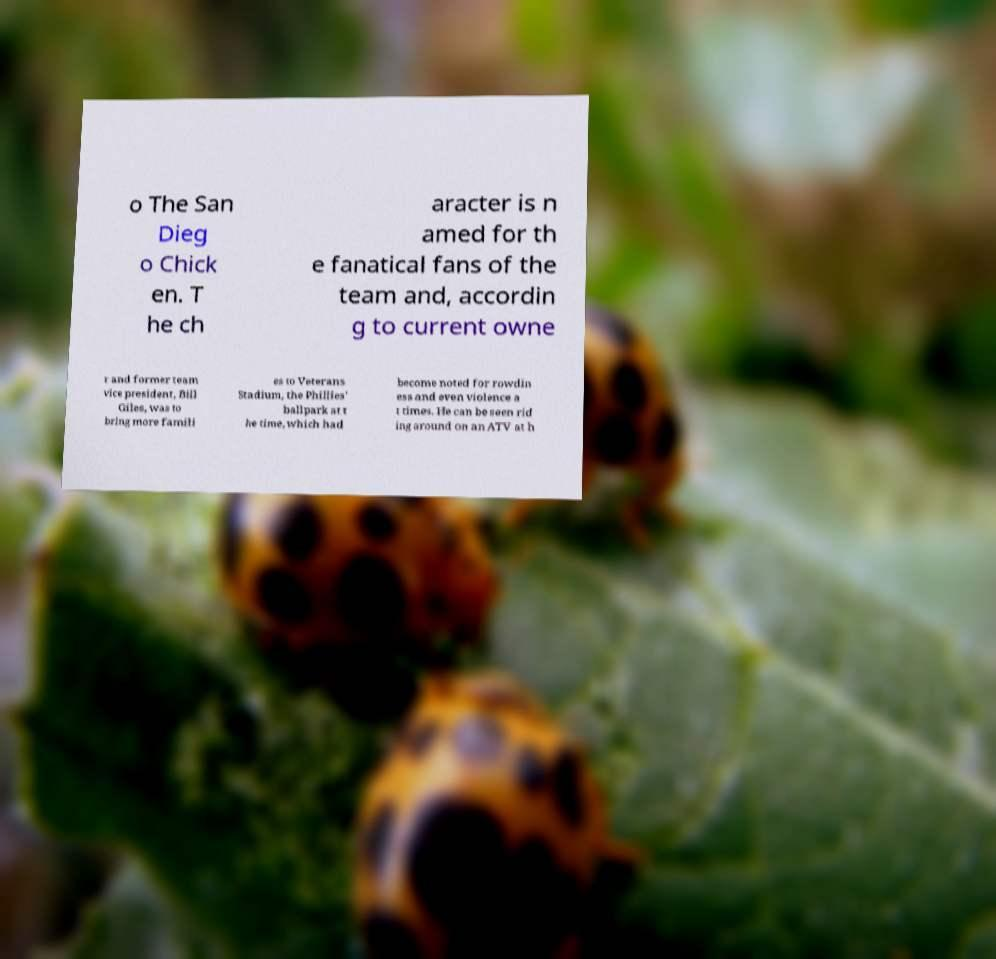There's text embedded in this image that I need extracted. Can you transcribe it verbatim? o The San Dieg o Chick en. T he ch aracter is n amed for th e fanatical fans of the team and, accordin g to current owne r and former team vice president, Bill Giles, was to bring more famili es to Veterans Stadium, the Phillies' ballpark at t he time, which had become noted for rowdin ess and even violence a t times. He can be seen rid ing around on an ATV at h 